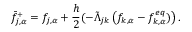Convert formula to latex. <formula><loc_0><loc_0><loc_500><loc_500>\bar { f } _ { j , \alpha } ^ { + } = f _ { j , \alpha } + \frac { h } { 2 } ( - \tilde { \Lambda } _ { j k } \left ( f _ { k , \alpha } - f _ { k , \alpha } ^ { e q } ) \right ) .</formula> 